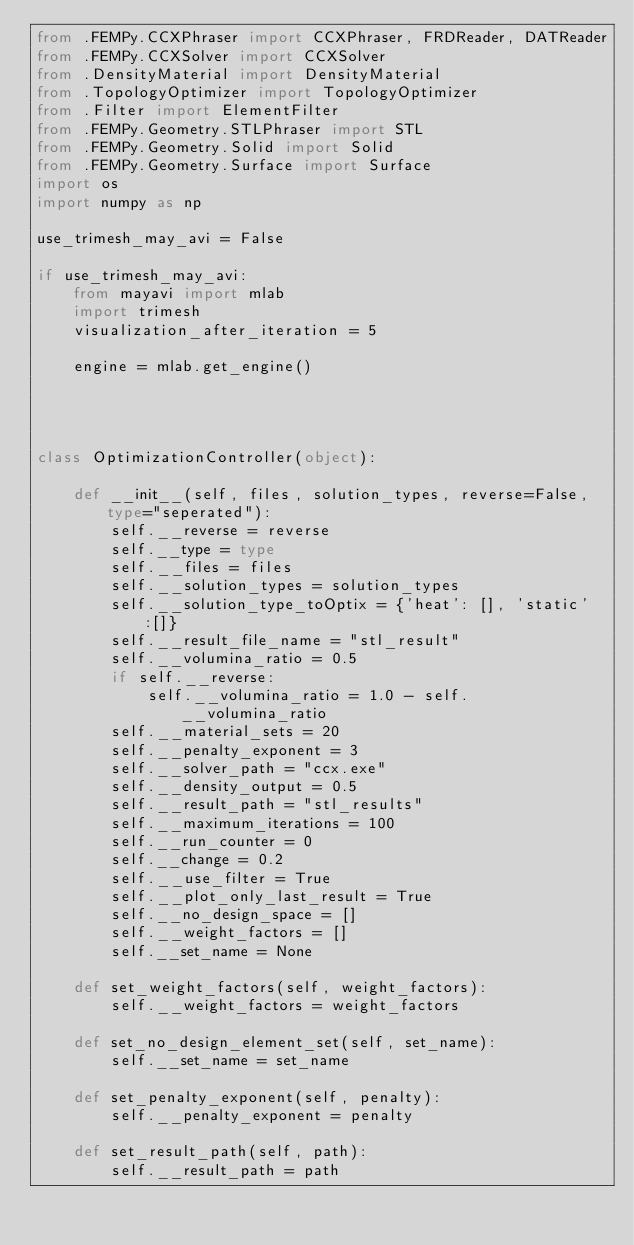<code> <loc_0><loc_0><loc_500><loc_500><_Python_>from .FEMPy.CCXPhraser import CCXPhraser, FRDReader, DATReader
from .FEMPy.CCXSolver import CCXSolver
from .DensityMaterial import DensityMaterial
from .TopologyOptimizer import TopologyOptimizer
from .Filter import ElementFilter
from .FEMPy.Geometry.STLPhraser import STL
from .FEMPy.Geometry.Solid import Solid
from .FEMPy.Geometry.Surface import Surface
import os
import numpy as np

use_trimesh_may_avi = False

if use_trimesh_may_avi:
    from mayavi import mlab
    import trimesh
    visualization_after_iteration = 5

    engine = mlab.get_engine()




class OptimizationController(object):

    def __init__(self, files, solution_types, reverse=False, type="seperated"):
        self.__reverse = reverse
        self.__type = type
        self.__files = files
        self.__solution_types = solution_types
        self.__solution_type_toOptix = {'heat': [], 'static':[]}
        self.__result_file_name = "stl_result"
        self.__volumina_ratio = 0.5
        if self.__reverse:
            self.__volumina_ratio = 1.0 - self.__volumina_ratio
        self.__material_sets = 20
        self.__penalty_exponent = 3
        self.__solver_path = "ccx.exe"
        self.__density_output = 0.5
        self.__result_path = "stl_results"
        self.__maximum_iterations = 100
        self.__run_counter = 0
        self.__change = 0.2
        self.__use_filter = True
        self.__plot_only_last_result = True
        self.__no_design_space = []
        self.__weight_factors = []
        self.__set_name = None

    def set_weight_factors(self, weight_factors):
        self.__weight_factors = weight_factors

    def set_no_design_element_set(self, set_name):
        self.__set_name = set_name

    def set_penalty_exponent(self, penalty):
        self.__penalty_exponent = penalty

    def set_result_path(self, path):
        self.__result_path = path
</code> 